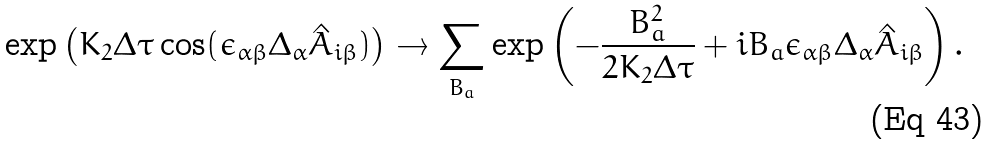<formula> <loc_0><loc_0><loc_500><loc_500>\exp \left ( K _ { 2 } \Delta \tau \cos ( \epsilon _ { \alpha \beta } \Delta _ { \alpha } \hat { A } _ { i \beta } ) \right ) \rightarrow \sum _ { B _ { a } } \exp \left ( - \frac { B _ { a } ^ { 2 } } { 2 K _ { 2 } \Delta \tau } + i B _ { a } \epsilon _ { \alpha \beta } \Delta _ { \alpha } \hat { A } _ { i \beta } \right ) .</formula> 